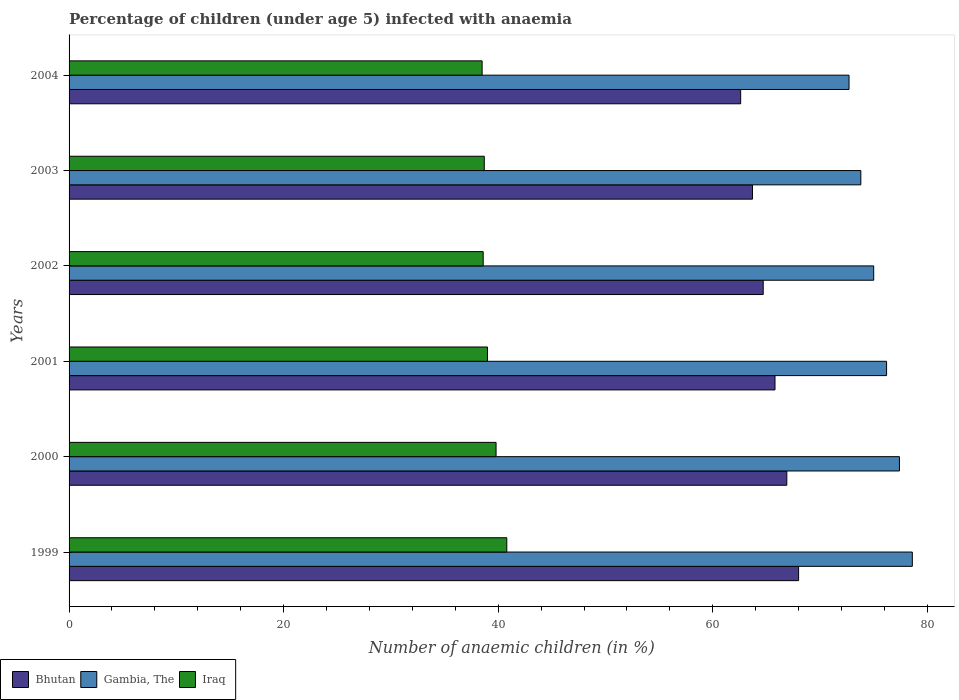How many different coloured bars are there?
Offer a very short reply. 3. Are the number of bars per tick equal to the number of legend labels?
Your response must be concise. Yes. Are the number of bars on each tick of the Y-axis equal?
Offer a terse response. Yes. What is the percentage of children infected with anaemia in in Iraq in 2004?
Provide a succinct answer. 38.5. Across all years, what is the maximum percentage of children infected with anaemia in in Gambia, The?
Make the answer very short. 78.6. Across all years, what is the minimum percentage of children infected with anaemia in in Bhutan?
Your response must be concise. 62.6. In which year was the percentage of children infected with anaemia in in Iraq maximum?
Your response must be concise. 1999. In which year was the percentage of children infected with anaemia in in Gambia, The minimum?
Your response must be concise. 2004. What is the total percentage of children infected with anaemia in in Bhutan in the graph?
Give a very brief answer. 391.7. What is the difference between the percentage of children infected with anaemia in in Gambia, The in 2000 and that in 2002?
Keep it short and to the point. 2.4. What is the difference between the percentage of children infected with anaemia in in Gambia, The in 2001 and the percentage of children infected with anaemia in in Bhutan in 2003?
Keep it short and to the point. 12.5. What is the average percentage of children infected with anaemia in in Gambia, The per year?
Keep it short and to the point. 75.62. In the year 2001, what is the difference between the percentage of children infected with anaemia in in Iraq and percentage of children infected with anaemia in in Bhutan?
Make the answer very short. -26.8. What is the difference between the highest and the lowest percentage of children infected with anaemia in in Iraq?
Offer a very short reply. 2.3. In how many years, is the percentage of children infected with anaemia in in Gambia, The greater than the average percentage of children infected with anaemia in in Gambia, The taken over all years?
Ensure brevity in your answer.  3. What does the 3rd bar from the top in 2000 represents?
Offer a very short reply. Bhutan. What does the 2nd bar from the bottom in 2000 represents?
Make the answer very short. Gambia, The. How many bars are there?
Ensure brevity in your answer.  18. What is the difference between two consecutive major ticks on the X-axis?
Provide a succinct answer. 20. Are the values on the major ticks of X-axis written in scientific E-notation?
Offer a very short reply. No. Does the graph contain any zero values?
Provide a succinct answer. No. How many legend labels are there?
Offer a very short reply. 3. How are the legend labels stacked?
Provide a short and direct response. Horizontal. What is the title of the graph?
Keep it short and to the point. Percentage of children (under age 5) infected with anaemia. What is the label or title of the X-axis?
Your answer should be very brief. Number of anaemic children (in %). What is the label or title of the Y-axis?
Ensure brevity in your answer.  Years. What is the Number of anaemic children (in %) of Bhutan in 1999?
Your answer should be very brief. 68. What is the Number of anaemic children (in %) of Gambia, The in 1999?
Keep it short and to the point. 78.6. What is the Number of anaemic children (in %) of Iraq in 1999?
Offer a very short reply. 40.8. What is the Number of anaemic children (in %) in Bhutan in 2000?
Provide a succinct answer. 66.9. What is the Number of anaemic children (in %) in Gambia, The in 2000?
Keep it short and to the point. 77.4. What is the Number of anaemic children (in %) in Iraq in 2000?
Provide a succinct answer. 39.8. What is the Number of anaemic children (in %) in Bhutan in 2001?
Make the answer very short. 65.8. What is the Number of anaemic children (in %) of Gambia, The in 2001?
Your answer should be compact. 76.2. What is the Number of anaemic children (in %) of Iraq in 2001?
Offer a terse response. 39. What is the Number of anaemic children (in %) of Bhutan in 2002?
Your answer should be very brief. 64.7. What is the Number of anaemic children (in %) of Gambia, The in 2002?
Offer a terse response. 75. What is the Number of anaemic children (in %) in Iraq in 2002?
Your response must be concise. 38.6. What is the Number of anaemic children (in %) of Bhutan in 2003?
Your response must be concise. 63.7. What is the Number of anaemic children (in %) of Gambia, The in 2003?
Make the answer very short. 73.8. What is the Number of anaemic children (in %) in Iraq in 2003?
Give a very brief answer. 38.7. What is the Number of anaemic children (in %) in Bhutan in 2004?
Ensure brevity in your answer.  62.6. What is the Number of anaemic children (in %) in Gambia, The in 2004?
Offer a very short reply. 72.7. What is the Number of anaemic children (in %) of Iraq in 2004?
Keep it short and to the point. 38.5. Across all years, what is the maximum Number of anaemic children (in %) of Gambia, The?
Ensure brevity in your answer.  78.6. Across all years, what is the maximum Number of anaemic children (in %) in Iraq?
Offer a very short reply. 40.8. Across all years, what is the minimum Number of anaemic children (in %) of Bhutan?
Ensure brevity in your answer.  62.6. Across all years, what is the minimum Number of anaemic children (in %) in Gambia, The?
Your answer should be very brief. 72.7. Across all years, what is the minimum Number of anaemic children (in %) of Iraq?
Offer a terse response. 38.5. What is the total Number of anaemic children (in %) in Bhutan in the graph?
Provide a short and direct response. 391.7. What is the total Number of anaemic children (in %) of Gambia, The in the graph?
Keep it short and to the point. 453.7. What is the total Number of anaemic children (in %) of Iraq in the graph?
Offer a terse response. 235.4. What is the difference between the Number of anaemic children (in %) of Bhutan in 1999 and that in 2000?
Keep it short and to the point. 1.1. What is the difference between the Number of anaemic children (in %) in Iraq in 1999 and that in 2000?
Keep it short and to the point. 1. What is the difference between the Number of anaemic children (in %) of Bhutan in 1999 and that in 2001?
Offer a terse response. 2.2. What is the difference between the Number of anaemic children (in %) of Iraq in 1999 and that in 2001?
Offer a very short reply. 1.8. What is the difference between the Number of anaemic children (in %) of Bhutan in 1999 and that in 2003?
Provide a succinct answer. 4.3. What is the difference between the Number of anaemic children (in %) in Bhutan in 1999 and that in 2004?
Your response must be concise. 5.4. What is the difference between the Number of anaemic children (in %) of Gambia, The in 1999 and that in 2004?
Your answer should be very brief. 5.9. What is the difference between the Number of anaemic children (in %) in Bhutan in 2000 and that in 2001?
Make the answer very short. 1.1. What is the difference between the Number of anaemic children (in %) of Gambia, The in 2000 and that in 2001?
Provide a short and direct response. 1.2. What is the difference between the Number of anaemic children (in %) in Iraq in 2000 and that in 2001?
Provide a short and direct response. 0.8. What is the difference between the Number of anaemic children (in %) of Gambia, The in 2000 and that in 2002?
Offer a very short reply. 2.4. What is the difference between the Number of anaemic children (in %) of Bhutan in 2000 and that in 2003?
Your response must be concise. 3.2. What is the difference between the Number of anaemic children (in %) of Gambia, The in 2000 and that in 2003?
Offer a terse response. 3.6. What is the difference between the Number of anaemic children (in %) of Bhutan in 2000 and that in 2004?
Ensure brevity in your answer.  4.3. What is the difference between the Number of anaemic children (in %) of Iraq in 2000 and that in 2004?
Offer a very short reply. 1.3. What is the difference between the Number of anaemic children (in %) in Iraq in 2001 and that in 2003?
Make the answer very short. 0.3. What is the difference between the Number of anaemic children (in %) in Gambia, The in 2001 and that in 2004?
Give a very brief answer. 3.5. What is the difference between the Number of anaemic children (in %) of Iraq in 2001 and that in 2004?
Your answer should be compact. 0.5. What is the difference between the Number of anaemic children (in %) in Bhutan in 2002 and that in 2003?
Offer a terse response. 1. What is the difference between the Number of anaemic children (in %) of Iraq in 2002 and that in 2003?
Make the answer very short. -0.1. What is the difference between the Number of anaemic children (in %) of Gambia, The in 2002 and that in 2004?
Your answer should be very brief. 2.3. What is the difference between the Number of anaemic children (in %) in Bhutan in 2003 and that in 2004?
Provide a succinct answer. 1.1. What is the difference between the Number of anaemic children (in %) of Iraq in 2003 and that in 2004?
Your answer should be compact. 0.2. What is the difference between the Number of anaemic children (in %) of Bhutan in 1999 and the Number of anaemic children (in %) of Iraq in 2000?
Offer a very short reply. 28.2. What is the difference between the Number of anaemic children (in %) of Gambia, The in 1999 and the Number of anaemic children (in %) of Iraq in 2000?
Make the answer very short. 38.8. What is the difference between the Number of anaemic children (in %) in Bhutan in 1999 and the Number of anaemic children (in %) in Gambia, The in 2001?
Provide a succinct answer. -8.2. What is the difference between the Number of anaemic children (in %) of Gambia, The in 1999 and the Number of anaemic children (in %) of Iraq in 2001?
Keep it short and to the point. 39.6. What is the difference between the Number of anaemic children (in %) in Bhutan in 1999 and the Number of anaemic children (in %) in Gambia, The in 2002?
Your response must be concise. -7. What is the difference between the Number of anaemic children (in %) of Bhutan in 1999 and the Number of anaemic children (in %) of Iraq in 2002?
Keep it short and to the point. 29.4. What is the difference between the Number of anaemic children (in %) of Bhutan in 1999 and the Number of anaemic children (in %) of Iraq in 2003?
Offer a terse response. 29.3. What is the difference between the Number of anaemic children (in %) of Gambia, The in 1999 and the Number of anaemic children (in %) of Iraq in 2003?
Give a very brief answer. 39.9. What is the difference between the Number of anaemic children (in %) in Bhutan in 1999 and the Number of anaemic children (in %) in Gambia, The in 2004?
Your response must be concise. -4.7. What is the difference between the Number of anaemic children (in %) of Bhutan in 1999 and the Number of anaemic children (in %) of Iraq in 2004?
Your response must be concise. 29.5. What is the difference between the Number of anaemic children (in %) of Gambia, The in 1999 and the Number of anaemic children (in %) of Iraq in 2004?
Give a very brief answer. 40.1. What is the difference between the Number of anaemic children (in %) of Bhutan in 2000 and the Number of anaemic children (in %) of Gambia, The in 2001?
Provide a short and direct response. -9.3. What is the difference between the Number of anaemic children (in %) in Bhutan in 2000 and the Number of anaemic children (in %) in Iraq in 2001?
Your answer should be very brief. 27.9. What is the difference between the Number of anaemic children (in %) in Gambia, The in 2000 and the Number of anaemic children (in %) in Iraq in 2001?
Keep it short and to the point. 38.4. What is the difference between the Number of anaemic children (in %) in Bhutan in 2000 and the Number of anaemic children (in %) in Gambia, The in 2002?
Offer a very short reply. -8.1. What is the difference between the Number of anaemic children (in %) in Bhutan in 2000 and the Number of anaemic children (in %) in Iraq in 2002?
Ensure brevity in your answer.  28.3. What is the difference between the Number of anaemic children (in %) of Gambia, The in 2000 and the Number of anaemic children (in %) of Iraq in 2002?
Your answer should be compact. 38.8. What is the difference between the Number of anaemic children (in %) of Bhutan in 2000 and the Number of anaemic children (in %) of Gambia, The in 2003?
Offer a terse response. -6.9. What is the difference between the Number of anaemic children (in %) of Bhutan in 2000 and the Number of anaemic children (in %) of Iraq in 2003?
Give a very brief answer. 28.2. What is the difference between the Number of anaemic children (in %) of Gambia, The in 2000 and the Number of anaemic children (in %) of Iraq in 2003?
Provide a succinct answer. 38.7. What is the difference between the Number of anaemic children (in %) in Bhutan in 2000 and the Number of anaemic children (in %) in Iraq in 2004?
Your answer should be compact. 28.4. What is the difference between the Number of anaemic children (in %) in Gambia, The in 2000 and the Number of anaemic children (in %) in Iraq in 2004?
Offer a terse response. 38.9. What is the difference between the Number of anaemic children (in %) in Bhutan in 2001 and the Number of anaemic children (in %) in Gambia, The in 2002?
Make the answer very short. -9.2. What is the difference between the Number of anaemic children (in %) in Bhutan in 2001 and the Number of anaemic children (in %) in Iraq in 2002?
Your answer should be very brief. 27.2. What is the difference between the Number of anaemic children (in %) in Gambia, The in 2001 and the Number of anaemic children (in %) in Iraq in 2002?
Your answer should be very brief. 37.6. What is the difference between the Number of anaemic children (in %) in Bhutan in 2001 and the Number of anaemic children (in %) in Iraq in 2003?
Keep it short and to the point. 27.1. What is the difference between the Number of anaemic children (in %) of Gambia, The in 2001 and the Number of anaemic children (in %) of Iraq in 2003?
Offer a terse response. 37.5. What is the difference between the Number of anaemic children (in %) in Bhutan in 2001 and the Number of anaemic children (in %) in Gambia, The in 2004?
Ensure brevity in your answer.  -6.9. What is the difference between the Number of anaemic children (in %) of Bhutan in 2001 and the Number of anaemic children (in %) of Iraq in 2004?
Make the answer very short. 27.3. What is the difference between the Number of anaemic children (in %) in Gambia, The in 2001 and the Number of anaemic children (in %) in Iraq in 2004?
Provide a short and direct response. 37.7. What is the difference between the Number of anaemic children (in %) in Bhutan in 2002 and the Number of anaemic children (in %) in Gambia, The in 2003?
Your answer should be very brief. -9.1. What is the difference between the Number of anaemic children (in %) of Gambia, The in 2002 and the Number of anaemic children (in %) of Iraq in 2003?
Offer a very short reply. 36.3. What is the difference between the Number of anaemic children (in %) in Bhutan in 2002 and the Number of anaemic children (in %) in Iraq in 2004?
Your answer should be compact. 26.2. What is the difference between the Number of anaemic children (in %) of Gambia, The in 2002 and the Number of anaemic children (in %) of Iraq in 2004?
Your answer should be compact. 36.5. What is the difference between the Number of anaemic children (in %) of Bhutan in 2003 and the Number of anaemic children (in %) of Gambia, The in 2004?
Your response must be concise. -9. What is the difference between the Number of anaemic children (in %) in Bhutan in 2003 and the Number of anaemic children (in %) in Iraq in 2004?
Provide a succinct answer. 25.2. What is the difference between the Number of anaemic children (in %) of Gambia, The in 2003 and the Number of anaemic children (in %) of Iraq in 2004?
Make the answer very short. 35.3. What is the average Number of anaemic children (in %) in Bhutan per year?
Offer a terse response. 65.28. What is the average Number of anaemic children (in %) in Gambia, The per year?
Your answer should be compact. 75.62. What is the average Number of anaemic children (in %) of Iraq per year?
Provide a succinct answer. 39.23. In the year 1999, what is the difference between the Number of anaemic children (in %) of Bhutan and Number of anaemic children (in %) of Iraq?
Ensure brevity in your answer.  27.2. In the year 1999, what is the difference between the Number of anaemic children (in %) in Gambia, The and Number of anaemic children (in %) in Iraq?
Provide a succinct answer. 37.8. In the year 2000, what is the difference between the Number of anaemic children (in %) of Bhutan and Number of anaemic children (in %) of Gambia, The?
Provide a short and direct response. -10.5. In the year 2000, what is the difference between the Number of anaemic children (in %) of Bhutan and Number of anaemic children (in %) of Iraq?
Make the answer very short. 27.1. In the year 2000, what is the difference between the Number of anaemic children (in %) of Gambia, The and Number of anaemic children (in %) of Iraq?
Keep it short and to the point. 37.6. In the year 2001, what is the difference between the Number of anaemic children (in %) of Bhutan and Number of anaemic children (in %) of Gambia, The?
Your answer should be compact. -10.4. In the year 2001, what is the difference between the Number of anaemic children (in %) in Bhutan and Number of anaemic children (in %) in Iraq?
Offer a terse response. 26.8. In the year 2001, what is the difference between the Number of anaemic children (in %) in Gambia, The and Number of anaemic children (in %) in Iraq?
Your answer should be compact. 37.2. In the year 2002, what is the difference between the Number of anaemic children (in %) in Bhutan and Number of anaemic children (in %) in Iraq?
Your answer should be very brief. 26.1. In the year 2002, what is the difference between the Number of anaemic children (in %) in Gambia, The and Number of anaemic children (in %) in Iraq?
Offer a terse response. 36.4. In the year 2003, what is the difference between the Number of anaemic children (in %) in Bhutan and Number of anaemic children (in %) in Gambia, The?
Provide a short and direct response. -10.1. In the year 2003, what is the difference between the Number of anaemic children (in %) in Bhutan and Number of anaemic children (in %) in Iraq?
Your answer should be very brief. 25. In the year 2003, what is the difference between the Number of anaemic children (in %) of Gambia, The and Number of anaemic children (in %) of Iraq?
Your answer should be very brief. 35.1. In the year 2004, what is the difference between the Number of anaemic children (in %) in Bhutan and Number of anaemic children (in %) in Gambia, The?
Provide a succinct answer. -10.1. In the year 2004, what is the difference between the Number of anaemic children (in %) in Bhutan and Number of anaemic children (in %) in Iraq?
Offer a terse response. 24.1. In the year 2004, what is the difference between the Number of anaemic children (in %) of Gambia, The and Number of anaemic children (in %) of Iraq?
Your response must be concise. 34.2. What is the ratio of the Number of anaemic children (in %) in Bhutan in 1999 to that in 2000?
Your answer should be very brief. 1.02. What is the ratio of the Number of anaemic children (in %) in Gambia, The in 1999 to that in 2000?
Offer a very short reply. 1.02. What is the ratio of the Number of anaemic children (in %) in Iraq in 1999 to that in 2000?
Give a very brief answer. 1.03. What is the ratio of the Number of anaemic children (in %) in Bhutan in 1999 to that in 2001?
Your response must be concise. 1.03. What is the ratio of the Number of anaemic children (in %) in Gambia, The in 1999 to that in 2001?
Offer a very short reply. 1.03. What is the ratio of the Number of anaemic children (in %) of Iraq in 1999 to that in 2001?
Offer a terse response. 1.05. What is the ratio of the Number of anaemic children (in %) in Bhutan in 1999 to that in 2002?
Make the answer very short. 1.05. What is the ratio of the Number of anaemic children (in %) in Gambia, The in 1999 to that in 2002?
Give a very brief answer. 1.05. What is the ratio of the Number of anaemic children (in %) of Iraq in 1999 to that in 2002?
Provide a short and direct response. 1.06. What is the ratio of the Number of anaemic children (in %) in Bhutan in 1999 to that in 2003?
Provide a succinct answer. 1.07. What is the ratio of the Number of anaemic children (in %) of Gambia, The in 1999 to that in 2003?
Give a very brief answer. 1.06. What is the ratio of the Number of anaemic children (in %) in Iraq in 1999 to that in 2003?
Provide a short and direct response. 1.05. What is the ratio of the Number of anaemic children (in %) of Bhutan in 1999 to that in 2004?
Provide a succinct answer. 1.09. What is the ratio of the Number of anaemic children (in %) of Gambia, The in 1999 to that in 2004?
Give a very brief answer. 1.08. What is the ratio of the Number of anaemic children (in %) of Iraq in 1999 to that in 2004?
Your answer should be very brief. 1.06. What is the ratio of the Number of anaemic children (in %) of Bhutan in 2000 to that in 2001?
Ensure brevity in your answer.  1.02. What is the ratio of the Number of anaemic children (in %) of Gambia, The in 2000 to that in 2001?
Offer a very short reply. 1.02. What is the ratio of the Number of anaemic children (in %) in Iraq in 2000 to that in 2001?
Offer a very short reply. 1.02. What is the ratio of the Number of anaemic children (in %) of Bhutan in 2000 to that in 2002?
Offer a very short reply. 1.03. What is the ratio of the Number of anaemic children (in %) of Gambia, The in 2000 to that in 2002?
Your answer should be very brief. 1.03. What is the ratio of the Number of anaemic children (in %) in Iraq in 2000 to that in 2002?
Give a very brief answer. 1.03. What is the ratio of the Number of anaemic children (in %) in Bhutan in 2000 to that in 2003?
Provide a short and direct response. 1.05. What is the ratio of the Number of anaemic children (in %) in Gambia, The in 2000 to that in 2003?
Ensure brevity in your answer.  1.05. What is the ratio of the Number of anaemic children (in %) in Iraq in 2000 to that in 2003?
Offer a terse response. 1.03. What is the ratio of the Number of anaemic children (in %) of Bhutan in 2000 to that in 2004?
Keep it short and to the point. 1.07. What is the ratio of the Number of anaemic children (in %) of Gambia, The in 2000 to that in 2004?
Offer a very short reply. 1.06. What is the ratio of the Number of anaemic children (in %) in Iraq in 2000 to that in 2004?
Provide a succinct answer. 1.03. What is the ratio of the Number of anaemic children (in %) in Bhutan in 2001 to that in 2002?
Keep it short and to the point. 1.02. What is the ratio of the Number of anaemic children (in %) of Iraq in 2001 to that in 2002?
Make the answer very short. 1.01. What is the ratio of the Number of anaemic children (in %) of Bhutan in 2001 to that in 2003?
Your response must be concise. 1.03. What is the ratio of the Number of anaemic children (in %) of Gambia, The in 2001 to that in 2003?
Keep it short and to the point. 1.03. What is the ratio of the Number of anaemic children (in %) in Iraq in 2001 to that in 2003?
Make the answer very short. 1.01. What is the ratio of the Number of anaemic children (in %) in Bhutan in 2001 to that in 2004?
Your answer should be very brief. 1.05. What is the ratio of the Number of anaemic children (in %) of Gambia, The in 2001 to that in 2004?
Your answer should be compact. 1.05. What is the ratio of the Number of anaemic children (in %) of Bhutan in 2002 to that in 2003?
Provide a succinct answer. 1.02. What is the ratio of the Number of anaemic children (in %) in Gambia, The in 2002 to that in 2003?
Offer a terse response. 1.02. What is the ratio of the Number of anaemic children (in %) in Bhutan in 2002 to that in 2004?
Provide a succinct answer. 1.03. What is the ratio of the Number of anaemic children (in %) of Gambia, The in 2002 to that in 2004?
Your response must be concise. 1.03. What is the ratio of the Number of anaemic children (in %) of Iraq in 2002 to that in 2004?
Keep it short and to the point. 1. What is the ratio of the Number of anaemic children (in %) in Bhutan in 2003 to that in 2004?
Provide a succinct answer. 1.02. What is the ratio of the Number of anaemic children (in %) of Gambia, The in 2003 to that in 2004?
Provide a short and direct response. 1.02. What is the ratio of the Number of anaemic children (in %) of Iraq in 2003 to that in 2004?
Make the answer very short. 1.01. What is the difference between the highest and the second highest Number of anaemic children (in %) of Gambia, The?
Offer a terse response. 1.2. What is the difference between the highest and the second highest Number of anaemic children (in %) of Iraq?
Offer a very short reply. 1. What is the difference between the highest and the lowest Number of anaemic children (in %) in Bhutan?
Provide a succinct answer. 5.4. What is the difference between the highest and the lowest Number of anaemic children (in %) of Gambia, The?
Keep it short and to the point. 5.9. What is the difference between the highest and the lowest Number of anaemic children (in %) of Iraq?
Give a very brief answer. 2.3. 